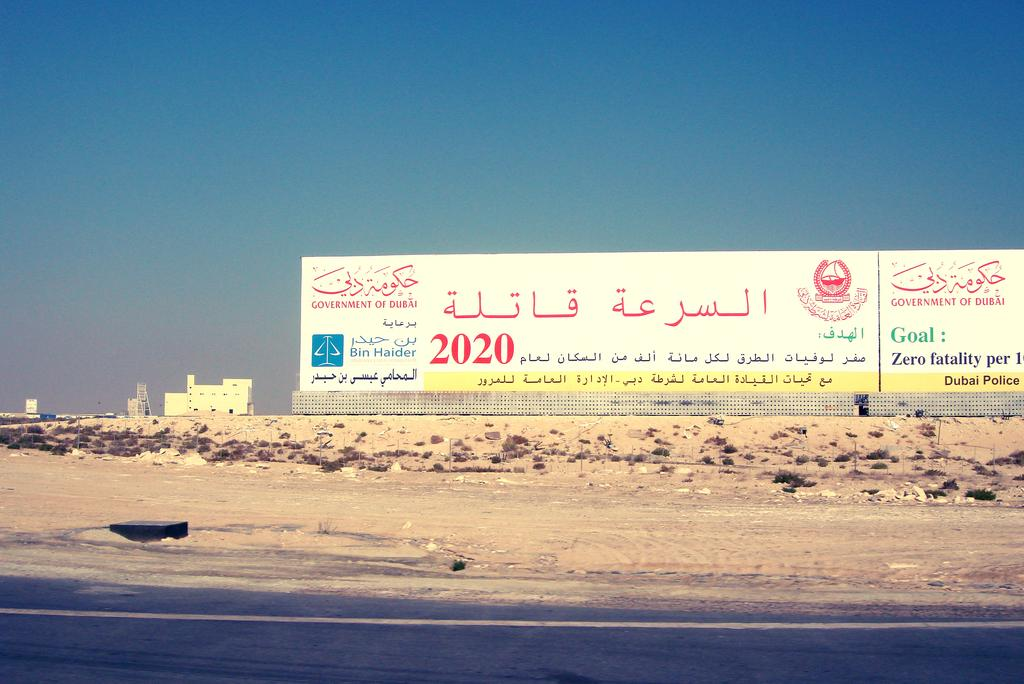<image>
Write a terse but informative summary of the picture. the year 2020 is on the white poster in the desert 